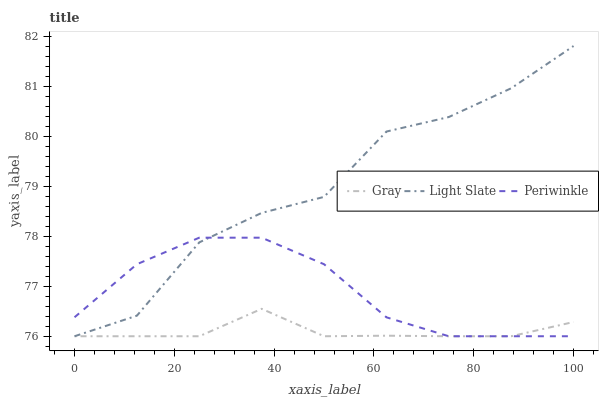Does Periwinkle have the minimum area under the curve?
Answer yes or no. No. Does Periwinkle have the maximum area under the curve?
Answer yes or no. No. Is Periwinkle the smoothest?
Answer yes or no. No. Is Periwinkle the roughest?
Answer yes or no. No. Does Periwinkle have the highest value?
Answer yes or no. No. 